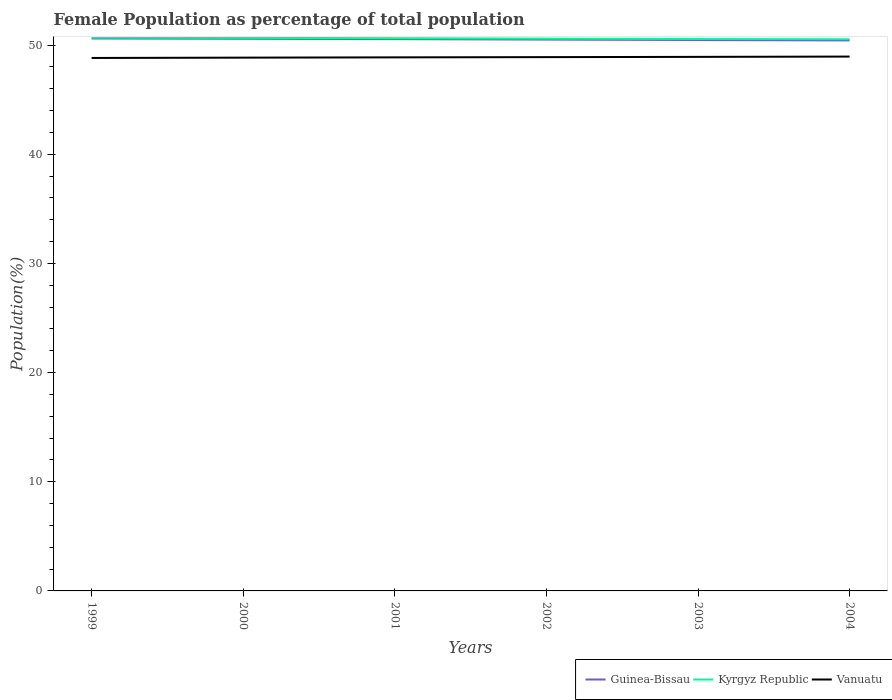Across all years, what is the maximum female population in in Guinea-Bissau?
Keep it short and to the point. 50.43. In which year was the female population in in Vanuatu maximum?
Offer a very short reply. 1999. What is the total female population in in Kyrgyz Republic in the graph?
Offer a very short reply. 0.06. What is the difference between the highest and the second highest female population in in Vanuatu?
Make the answer very short. 0.13. Is the female population in in Kyrgyz Republic strictly greater than the female population in in Guinea-Bissau over the years?
Ensure brevity in your answer.  No. Are the values on the major ticks of Y-axis written in scientific E-notation?
Keep it short and to the point. No. Does the graph contain grids?
Your answer should be very brief. No. How are the legend labels stacked?
Provide a succinct answer. Horizontal. What is the title of the graph?
Offer a terse response. Female Population as percentage of total population. What is the label or title of the Y-axis?
Give a very brief answer. Population(%). What is the Population(%) in Guinea-Bissau in 1999?
Give a very brief answer. 50.61. What is the Population(%) of Kyrgyz Republic in 1999?
Your answer should be compact. 50.69. What is the Population(%) of Vanuatu in 1999?
Your answer should be very brief. 48.83. What is the Population(%) of Guinea-Bissau in 2000?
Offer a terse response. 50.59. What is the Population(%) of Kyrgyz Republic in 2000?
Offer a terse response. 50.67. What is the Population(%) in Vanuatu in 2000?
Offer a terse response. 48.86. What is the Population(%) in Guinea-Bissau in 2001?
Give a very brief answer. 50.55. What is the Population(%) in Kyrgyz Republic in 2001?
Give a very brief answer. 50.64. What is the Population(%) of Vanuatu in 2001?
Make the answer very short. 48.88. What is the Population(%) in Guinea-Bissau in 2002?
Offer a very short reply. 50.51. What is the Population(%) in Kyrgyz Republic in 2002?
Give a very brief answer. 50.6. What is the Population(%) in Vanuatu in 2002?
Your response must be concise. 48.9. What is the Population(%) in Guinea-Bissau in 2003?
Ensure brevity in your answer.  50.47. What is the Population(%) in Kyrgyz Republic in 2003?
Your answer should be compact. 50.56. What is the Population(%) in Vanuatu in 2003?
Your response must be concise. 48.93. What is the Population(%) in Guinea-Bissau in 2004?
Offer a very short reply. 50.43. What is the Population(%) in Kyrgyz Republic in 2004?
Provide a short and direct response. 50.54. What is the Population(%) of Vanuatu in 2004?
Make the answer very short. 48.96. Across all years, what is the maximum Population(%) of Guinea-Bissau?
Ensure brevity in your answer.  50.61. Across all years, what is the maximum Population(%) in Kyrgyz Republic?
Keep it short and to the point. 50.69. Across all years, what is the maximum Population(%) of Vanuatu?
Give a very brief answer. 48.96. Across all years, what is the minimum Population(%) in Guinea-Bissau?
Make the answer very short. 50.43. Across all years, what is the minimum Population(%) of Kyrgyz Republic?
Your answer should be compact. 50.54. Across all years, what is the minimum Population(%) in Vanuatu?
Give a very brief answer. 48.83. What is the total Population(%) in Guinea-Bissau in the graph?
Provide a succinct answer. 303.17. What is the total Population(%) in Kyrgyz Republic in the graph?
Ensure brevity in your answer.  303.71. What is the total Population(%) of Vanuatu in the graph?
Ensure brevity in your answer.  293.36. What is the difference between the Population(%) of Guinea-Bissau in 1999 and that in 2000?
Offer a very short reply. 0.03. What is the difference between the Population(%) of Kyrgyz Republic in 1999 and that in 2000?
Ensure brevity in your answer.  0.02. What is the difference between the Population(%) in Vanuatu in 1999 and that in 2000?
Keep it short and to the point. -0.03. What is the difference between the Population(%) in Guinea-Bissau in 1999 and that in 2001?
Keep it short and to the point. 0.06. What is the difference between the Population(%) in Kyrgyz Republic in 1999 and that in 2001?
Give a very brief answer. 0.06. What is the difference between the Population(%) of Vanuatu in 1999 and that in 2001?
Offer a terse response. -0.06. What is the difference between the Population(%) of Guinea-Bissau in 1999 and that in 2002?
Offer a very short reply. 0.1. What is the difference between the Population(%) in Kyrgyz Republic in 1999 and that in 2002?
Offer a very short reply. 0.09. What is the difference between the Population(%) in Vanuatu in 1999 and that in 2002?
Your answer should be compact. -0.08. What is the difference between the Population(%) in Guinea-Bissau in 1999 and that in 2003?
Provide a short and direct response. 0.14. What is the difference between the Population(%) of Kyrgyz Republic in 1999 and that in 2003?
Make the answer very short. 0.13. What is the difference between the Population(%) in Vanuatu in 1999 and that in 2003?
Your response must be concise. -0.1. What is the difference between the Population(%) in Guinea-Bissau in 1999 and that in 2004?
Provide a short and direct response. 0.18. What is the difference between the Population(%) of Kyrgyz Republic in 1999 and that in 2004?
Your response must be concise. 0.15. What is the difference between the Population(%) in Vanuatu in 1999 and that in 2004?
Provide a succinct answer. -0.13. What is the difference between the Population(%) of Guinea-Bissau in 2000 and that in 2001?
Give a very brief answer. 0.03. What is the difference between the Population(%) in Kyrgyz Republic in 2000 and that in 2001?
Ensure brevity in your answer.  0.03. What is the difference between the Population(%) of Vanuatu in 2000 and that in 2001?
Your response must be concise. -0.03. What is the difference between the Population(%) of Guinea-Bissau in 2000 and that in 2002?
Offer a very short reply. 0.07. What is the difference between the Population(%) of Kyrgyz Republic in 2000 and that in 2002?
Keep it short and to the point. 0.07. What is the difference between the Population(%) of Vanuatu in 2000 and that in 2002?
Offer a terse response. -0.05. What is the difference between the Population(%) of Guinea-Bissau in 2000 and that in 2003?
Offer a terse response. 0.12. What is the difference between the Population(%) of Kyrgyz Republic in 2000 and that in 2003?
Your answer should be very brief. 0.11. What is the difference between the Population(%) of Vanuatu in 2000 and that in 2003?
Ensure brevity in your answer.  -0.07. What is the difference between the Population(%) of Guinea-Bissau in 2000 and that in 2004?
Offer a very short reply. 0.15. What is the difference between the Population(%) in Kyrgyz Republic in 2000 and that in 2004?
Provide a short and direct response. 0.13. What is the difference between the Population(%) in Vanuatu in 2000 and that in 2004?
Offer a terse response. -0.1. What is the difference between the Population(%) of Guinea-Bissau in 2001 and that in 2002?
Give a very brief answer. 0.04. What is the difference between the Population(%) in Kyrgyz Republic in 2001 and that in 2002?
Offer a very short reply. 0.04. What is the difference between the Population(%) in Vanuatu in 2001 and that in 2002?
Provide a succinct answer. -0.02. What is the difference between the Population(%) of Guinea-Bissau in 2001 and that in 2003?
Keep it short and to the point. 0.08. What is the difference between the Population(%) of Kyrgyz Republic in 2001 and that in 2003?
Your response must be concise. 0.07. What is the difference between the Population(%) in Vanuatu in 2001 and that in 2003?
Provide a short and direct response. -0.04. What is the difference between the Population(%) in Guinea-Bissau in 2001 and that in 2004?
Keep it short and to the point. 0.12. What is the difference between the Population(%) of Kyrgyz Republic in 2001 and that in 2004?
Your response must be concise. 0.1. What is the difference between the Population(%) in Vanuatu in 2001 and that in 2004?
Ensure brevity in your answer.  -0.07. What is the difference between the Population(%) of Guinea-Bissau in 2002 and that in 2003?
Your answer should be very brief. 0.04. What is the difference between the Population(%) in Kyrgyz Republic in 2002 and that in 2003?
Your answer should be compact. 0.04. What is the difference between the Population(%) of Vanuatu in 2002 and that in 2003?
Offer a terse response. -0.02. What is the difference between the Population(%) of Guinea-Bissau in 2002 and that in 2004?
Your response must be concise. 0.08. What is the difference between the Population(%) in Kyrgyz Republic in 2002 and that in 2004?
Your answer should be compact. 0.06. What is the difference between the Population(%) in Vanuatu in 2002 and that in 2004?
Keep it short and to the point. -0.05. What is the difference between the Population(%) of Guinea-Bissau in 2003 and that in 2004?
Offer a terse response. 0.04. What is the difference between the Population(%) of Kyrgyz Republic in 2003 and that in 2004?
Provide a short and direct response. 0.02. What is the difference between the Population(%) of Vanuatu in 2003 and that in 2004?
Your response must be concise. -0.03. What is the difference between the Population(%) of Guinea-Bissau in 1999 and the Population(%) of Kyrgyz Republic in 2000?
Your answer should be very brief. -0.06. What is the difference between the Population(%) in Guinea-Bissau in 1999 and the Population(%) in Vanuatu in 2000?
Offer a terse response. 1.75. What is the difference between the Population(%) in Kyrgyz Republic in 1999 and the Population(%) in Vanuatu in 2000?
Keep it short and to the point. 1.84. What is the difference between the Population(%) of Guinea-Bissau in 1999 and the Population(%) of Kyrgyz Republic in 2001?
Keep it short and to the point. -0.03. What is the difference between the Population(%) of Guinea-Bissau in 1999 and the Population(%) of Vanuatu in 2001?
Ensure brevity in your answer.  1.73. What is the difference between the Population(%) of Kyrgyz Republic in 1999 and the Population(%) of Vanuatu in 2001?
Keep it short and to the point. 1.81. What is the difference between the Population(%) of Guinea-Bissau in 1999 and the Population(%) of Kyrgyz Republic in 2002?
Make the answer very short. 0.01. What is the difference between the Population(%) in Guinea-Bissau in 1999 and the Population(%) in Vanuatu in 2002?
Provide a short and direct response. 1.71. What is the difference between the Population(%) of Kyrgyz Republic in 1999 and the Population(%) of Vanuatu in 2002?
Ensure brevity in your answer.  1.79. What is the difference between the Population(%) in Guinea-Bissau in 1999 and the Population(%) in Kyrgyz Republic in 2003?
Make the answer very short. 0.05. What is the difference between the Population(%) in Guinea-Bissau in 1999 and the Population(%) in Vanuatu in 2003?
Your response must be concise. 1.69. What is the difference between the Population(%) of Kyrgyz Republic in 1999 and the Population(%) of Vanuatu in 2003?
Give a very brief answer. 1.77. What is the difference between the Population(%) of Guinea-Bissau in 1999 and the Population(%) of Kyrgyz Republic in 2004?
Your response must be concise. 0.07. What is the difference between the Population(%) of Guinea-Bissau in 1999 and the Population(%) of Vanuatu in 2004?
Ensure brevity in your answer.  1.66. What is the difference between the Population(%) of Kyrgyz Republic in 1999 and the Population(%) of Vanuatu in 2004?
Ensure brevity in your answer.  1.74. What is the difference between the Population(%) in Guinea-Bissau in 2000 and the Population(%) in Kyrgyz Republic in 2001?
Ensure brevity in your answer.  -0.05. What is the difference between the Population(%) in Guinea-Bissau in 2000 and the Population(%) in Vanuatu in 2001?
Offer a very short reply. 1.7. What is the difference between the Population(%) of Kyrgyz Republic in 2000 and the Population(%) of Vanuatu in 2001?
Give a very brief answer. 1.79. What is the difference between the Population(%) of Guinea-Bissau in 2000 and the Population(%) of Kyrgyz Republic in 2002?
Your answer should be very brief. -0.01. What is the difference between the Population(%) of Guinea-Bissau in 2000 and the Population(%) of Vanuatu in 2002?
Give a very brief answer. 1.68. What is the difference between the Population(%) of Kyrgyz Republic in 2000 and the Population(%) of Vanuatu in 2002?
Offer a terse response. 1.77. What is the difference between the Population(%) in Guinea-Bissau in 2000 and the Population(%) in Kyrgyz Republic in 2003?
Offer a very short reply. 0.02. What is the difference between the Population(%) in Guinea-Bissau in 2000 and the Population(%) in Vanuatu in 2003?
Offer a terse response. 1.66. What is the difference between the Population(%) of Kyrgyz Republic in 2000 and the Population(%) of Vanuatu in 2003?
Ensure brevity in your answer.  1.74. What is the difference between the Population(%) in Guinea-Bissau in 2000 and the Population(%) in Kyrgyz Republic in 2004?
Your answer should be very brief. 0.04. What is the difference between the Population(%) in Guinea-Bissau in 2000 and the Population(%) in Vanuatu in 2004?
Your answer should be compact. 1.63. What is the difference between the Population(%) of Kyrgyz Republic in 2000 and the Population(%) of Vanuatu in 2004?
Your answer should be compact. 1.71. What is the difference between the Population(%) in Guinea-Bissau in 2001 and the Population(%) in Kyrgyz Republic in 2002?
Offer a very short reply. -0.05. What is the difference between the Population(%) in Guinea-Bissau in 2001 and the Population(%) in Vanuatu in 2002?
Ensure brevity in your answer.  1.65. What is the difference between the Population(%) in Kyrgyz Republic in 2001 and the Population(%) in Vanuatu in 2002?
Offer a very short reply. 1.73. What is the difference between the Population(%) of Guinea-Bissau in 2001 and the Population(%) of Kyrgyz Republic in 2003?
Ensure brevity in your answer.  -0.01. What is the difference between the Population(%) in Guinea-Bissau in 2001 and the Population(%) in Vanuatu in 2003?
Your answer should be very brief. 1.63. What is the difference between the Population(%) in Kyrgyz Republic in 2001 and the Population(%) in Vanuatu in 2003?
Provide a succinct answer. 1.71. What is the difference between the Population(%) in Guinea-Bissau in 2001 and the Population(%) in Kyrgyz Republic in 2004?
Your answer should be very brief. 0.01. What is the difference between the Population(%) in Guinea-Bissau in 2001 and the Population(%) in Vanuatu in 2004?
Make the answer very short. 1.6. What is the difference between the Population(%) in Kyrgyz Republic in 2001 and the Population(%) in Vanuatu in 2004?
Your answer should be very brief. 1.68. What is the difference between the Population(%) in Guinea-Bissau in 2002 and the Population(%) in Kyrgyz Republic in 2003?
Your response must be concise. -0.05. What is the difference between the Population(%) of Guinea-Bissau in 2002 and the Population(%) of Vanuatu in 2003?
Your answer should be very brief. 1.59. What is the difference between the Population(%) in Kyrgyz Republic in 2002 and the Population(%) in Vanuatu in 2003?
Ensure brevity in your answer.  1.67. What is the difference between the Population(%) in Guinea-Bissau in 2002 and the Population(%) in Kyrgyz Republic in 2004?
Provide a succinct answer. -0.03. What is the difference between the Population(%) of Guinea-Bissau in 2002 and the Population(%) of Vanuatu in 2004?
Your answer should be compact. 1.56. What is the difference between the Population(%) of Kyrgyz Republic in 2002 and the Population(%) of Vanuatu in 2004?
Your answer should be very brief. 1.65. What is the difference between the Population(%) in Guinea-Bissau in 2003 and the Population(%) in Kyrgyz Republic in 2004?
Your answer should be compact. -0.07. What is the difference between the Population(%) of Guinea-Bissau in 2003 and the Population(%) of Vanuatu in 2004?
Give a very brief answer. 1.52. What is the difference between the Population(%) in Kyrgyz Republic in 2003 and the Population(%) in Vanuatu in 2004?
Keep it short and to the point. 1.61. What is the average Population(%) in Guinea-Bissau per year?
Offer a very short reply. 50.53. What is the average Population(%) in Kyrgyz Republic per year?
Your response must be concise. 50.62. What is the average Population(%) in Vanuatu per year?
Give a very brief answer. 48.89. In the year 1999, what is the difference between the Population(%) in Guinea-Bissau and Population(%) in Kyrgyz Republic?
Keep it short and to the point. -0.08. In the year 1999, what is the difference between the Population(%) of Guinea-Bissau and Population(%) of Vanuatu?
Provide a succinct answer. 1.78. In the year 1999, what is the difference between the Population(%) of Kyrgyz Republic and Population(%) of Vanuatu?
Keep it short and to the point. 1.87. In the year 2000, what is the difference between the Population(%) in Guinea-Bissau and Population(%) in Kyrgyz Republic?
Ensure brevity in your answer.  -0.08. In the year 2000, what is the difference between the Population(%) of Guinea-Bissau and Population(%) of Vanuatu?
Provide a short and direct response. 1.73. In the year 2000, what is the difference between the Population(%) of Kyrgyz Republic and Population(%) of Vanuatu?
Your answer should be compact. 1.81. In the year 2001, what is the difference between the Population(%) of Guinea-Bissau and Population(%) of Kyrgyz Republic?
Ensure brevity in your answer.  -0.09. In the year 2001, what is the difference between the Population(%) in Guinea-Bissau and Population(%) in Vanuatu?
Provide a succinct answer. 1.67. In the year 2001, what is the difference between the Population(%) in Kyrgyz Republic and Population(%) in Vanuatu?
Ensure brevity in your answer.  1.76. In the year 2002, what is the difference between the Population(%) of Guinea-Bissau and Population(%) of Kyrgyz Republic?
Give a very brief answer. -0.09. In the year 2002, what is the difference between the Population(%) of Guinea-Bissau and Population(%) of Vanuatu?
Offer a very short reply. 1.61. In the year 2002, what is the difference between the Population(%) in Kyrgyz Republic and Population(%) in Vanuatu?
Offer a very short reply. 1.7. In the year 2003, what is the difference between the Population(%) of Guinea-Bissau and Population(%) of Kyrgyz Republic?
Provide a succinct answer. -0.09. In the year 2003, what is the difference between the Population(%) in Guinea-Bissau and Population(%) in Vanuatu?
Ensure brevity in your answer.  1.54. In the year 2003, what is the difference between the Population(%) in Kyrgyz Republic and Population(%) in Vanuatu?
Offer a very short reply. 1.64. In the year 2004, what is the difference between the Population(%) of Guinea-Bissau and Population(%) of Kyrgyz Republic?
Give a very brief answer. -0.11. In the year 2004, what is the difference between the Population(%) of Guinea-Bissau and Population(%) of Vanuatu?
Provide a succinct answer. 1.48. In the year 2004, what is the difference between the Population(%) in Kyrgyz Republic and Population(%) in Vanuatu?
Your answer should be very brief. 1.59. What is the ratio of the Population(%) of Kyrgyz Republic in 1999 to that in 2000?
Your response must be concise. 1. What is the ratio of the Population(%) in Vanuatu in 1999 to that in 2000?
Your answer should be compact. 1. What is the ratio of the Population(%) in Guinea-Bissau in 1999 to that in 2001?
Your response must be concise. 1. What is the ratio of the Population(%) in Vanuatu in 1999 to that in 2001?
Make the answer very short. 1. What is the ratio of the Population(%) in Kyrgyz Republic in 1999 to that in 2002?
Ensure brevity in your answer.  1. What is the ratio of the Population(%) in Vanuatu in 1999 to that in 2002?
Provide a short and direct response. 1. What is the ratio of the Population(%) of Guinea-Bissau in 1999 to that in 2004?
Your answer should be very brief. 1. What is the ratio of the Population(%) of Kyrgyz Republic in 1999 to that in 2004?
Offer a very short reply. 1. What is the ratio of the Population(%) in Vanuatu in 1999 to that in 2004?
Offer a very short reply. 1. What is the ratio of the Population(%) of Vanuatu in 2000 to that in 2001?
Ensure brevity in your answer.  1. What is the ratio of the Population(%) of Guinea-Bissau in 2000 to that in 2002?
Your answer should be compact. 1. What is the ratio of the Population(%) of Kyrgyz Republic in 2000 to that in 2002?
Your answer should be very brief. 1. What is the ratio of the Population(%) in Kyrgyz Republic in 2000 to that in 2003?
Offer a terse response. 1. What is the ratio of the Population(%) of Kyrgyz Republic in 2000 to that in 2004?
Make the answer very short. 1. What is the ratio of the Population(%) of Vanuatu in 2000 to that in 2004?
Provide a succinct answer. 1. What is the ratio of the Population(%) of Vanuatu in 2001 to that in 2002?
Provide a short and direct response. 1. What is the ratio of the Population(%) in Guinea-Bissau in 2001 to that in 2003?
Offer a terse response. 1. What is the ratio of the Population(%) in Kyrgyz Republic in 2001 to that in 2003?
Keep it short and to the point. 1. What is the ratio of the Population(%) in Guinea-Bissau in 2001 to that in 2004?
Your answer should be very brief. 1. What is the ratio of the Population(%) in Kyrgyz Republic in 2001 to that in 2004?
Give a very brief answer. 1. What is the ratio of the Population(%) of Kyrgyz Republic in 2002 to that in 2003?
Give a very brief answer. 1. What is the ratio of the Population(%) in Vanuatu in 2002 to that in 2004?
Keep it short and to the point. 1. What is the ratio of the Population(%) of Guinea-Bissau in 2003 to that in 2004?
Ensure brevity in your answer.  1. What is the ratio of the Population(%) in Kyrgyz Republic in 2003 to that in 2004?
Make the answer very short. 1. What is the difference between the highest and the second highest Population(%) of Guinea-Bissau?
Provide a short and direct response. 0.03. What is the difference between the highest and the second highest Population(%) in Kyrgyz Republic?
Offer a very short reply. 0.02. What is the difference between the highest and the second highest Population(%) in Vanuatu?
Your answer should be very brief. 0.03. What is the difference between the highest and the lowest Population(%) of Guinea-Bissau?
Give a very brief answer. 0.18. What is the difference between the highest and the lowest Population(%) in Kyrgyz Republic?
Keep it short and to the point. 0.15. What is the difference between the highest and the lowest Population(%) of Vanuatu?
Offer a very short reply. 0.13. 